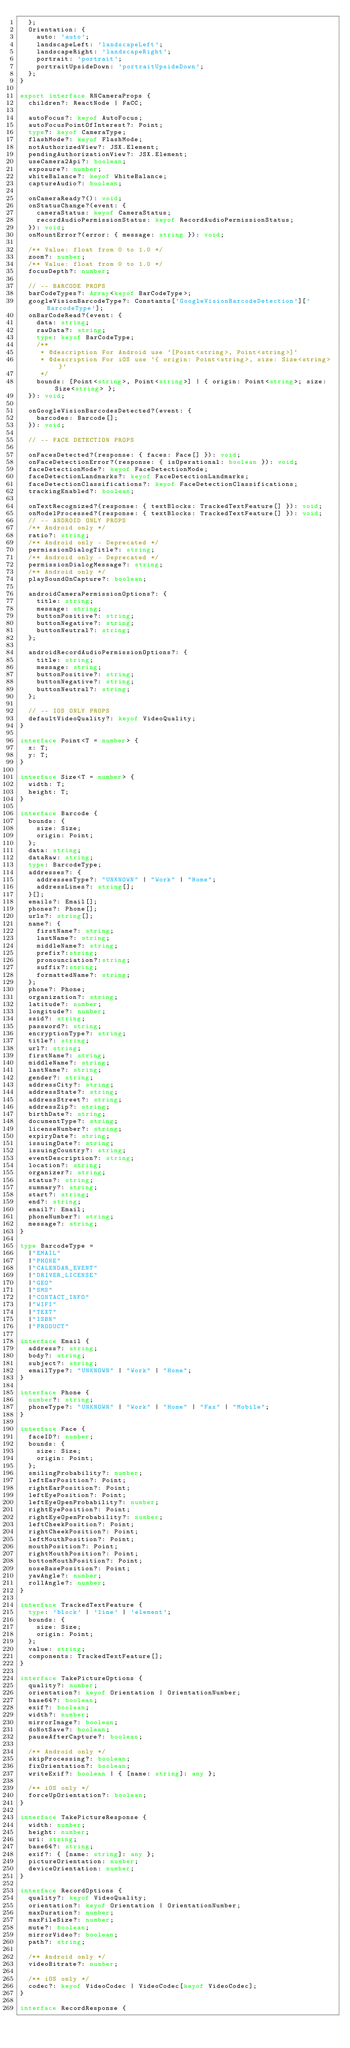Convert code to text. <code><loc_0><loc_0><loc_500><loc_500><_TypeScript_>  };
  Orientation: {
    auto: 'auto';
    landscapeLeft: 'landscapeLeft';
    landscapeRight: 'landscapeRight';
    portrait: 'portrait';
    portraitUpsideDown: 'portraitUpsideDown';
  };
}

export interface RNCameraProps {
  children?: ReactNode | FaCC;

  autoFocus?: keyof AutoFocus;
  autoFocusPointOfInterest?: Point;
  type?: keyof CameraType;
  flashMode?: keyof FlashMode;
  notAuthorizedView?: JSX.Element;
  pendingAuthorizationView?: JSX.Element;
  useCamera2Api?: boolean;
  exposure?: number;
  whiteBalance?: keyof WhiteBalance;
  captureAudio?: boolean;

  onCameraReady?(): void;
  onStatusChange?(event: {
    cameraStatus: keyof CameraStatus;
    recordAudioPermissionStatus: keyof RecordAudioPermissionStatus;
  }): void;
  onMountError?(error: { message: string }): void;

  /** Value: float from 0 to 1.0 */
  zoom?: number;
  /** Value: float from 0 to 1.0 */
  focusDepth?: number;

  // -- BARCODE PROPS
  barCodeTypes?: Array<keyof BarCodeType>;
  googleVisionBarcodeType?: Constants['GoogleVisionBarcodeDetection']['BarcodeType'];
  onBarCodeRead?(event: {
    data: string;
    rawData?: string;
    type: keyof BarCodeType;
    /**
     * @description For Android use `[Point<string>, Point<string>]`
     * @description For iOS use `{ origin: Point<string>, size: Size<string> }`
     */
    bounds: [Point<string>, Point<string>] | { origin: Point<string>; size: Size<string> };
  }): void;

  onGoogleVisionBarcodesDetected?(event: {
    barcodes: Barcode[];
  }): void;

  // -- FACE DETECTION PROPS

  onFacesDetected?(response: { faces: Face[] }): void;
  onFaceDetectionError?(response: { isOperational: boolean }): void;
  faceDetectionMode?: keyof FaceDetectionMode;
  faceDetectionLandmarks?: keyof FaceDetectionLandmarks;
  faceDetectionClassifications?: keyof FaceDetectionClassifications;
  trackingEnabled?: boolean;

  onTextRecognized?(response: { textBlocks: TrackedTextFeature[] }): void;
  onModelProcessed?(response: { textBlocks: TrackedTextFeature[] }): void;  
  // -- ANDROID ONLY PROPS
  /** Android only */
  ratio?: string;
  /** Android only - Deprecated */
  permissionDialogTitle?: string;
  /** Android only - Deprecated */
  permissionDialogMessage?: string;
  /** Android only */
  playSoundOnCapture?: boolean;

  androidCameraPermissionOptions?: {
    title: string;
    message: string;
    buttonPositive?: string;
    buttonNegative?: string;
    buttonNeutral?: string;
  };

  androidRecordAudioPermissionOptions?: {
    title: string;
    message: string;
    buttonPositive?: string;
    buttonNegative?: string;
    buttonNeutral?: string;
  };

  // -- IOS ONLY PROPS
  defaultVideoQuality?: keyof VideoQuality;
}

interface Point<T = number> {
  x: T;
  y: T;
}

interface Size<T = number> {
  width: T;
  height: T;
}

interface Barcode {
  bounds: {
    size: Size;
    origin: Point;
  };
  data: string;
  dataRaw: string;
  type: BarcodeType;
  addresses?: {
    addressesType?: "UNKNOWN" | "Work" | "Home";
    addressLines?: string[];
  }[];
  emails?: Email[];
  phones?: Phone[];
  urls?: string[];
  name?: {
    firstName?: string;
    lastName?: string;
    middleName?: string;
    prefix?:string;
    pronounciation?:string;
    suffix?:string;
    formattedName?: string;
  };
  phone?: Phone;
  organization?: string;
  latitude?: number;
  longitude?: number;
  ssid?: string;
  password?: string;
  encryptionType?: string;
  title?: string;
  url?: string;
  firstName?: string;
  middleName?: string;
  lastName?: string;
  gender?: string;
  addressCity?: string;
  addressState?: string;
  addressStreet?: string;
  addressZip?: string;
  birthDate?: string;
  documentType?: string;
  licenseNumber?: string;
  expiryDate?: string;
  issuingDate?: string;
  issuingCountry?: string;
  eventDescription?: string;
  location?: string;
  organizer?: string;
  status?: string;
  summary?: string;
  start?: string;
  end?: string;
  email?: Email;
  phoneNumber?: string;
  message?: string;
}

type BarcodeType =
  |"EMAIL"
  |"PHONE"
  |"CALENDAR_EVENT"
  |"DRIVER_LICENSE"
  |"GEO"
  |"SMS"
  |"CONTACT_INFO"
  |"WIFI"
  |"TEXT"
  |"ISBN"
  |"PRODUCT"

interface Email {
  address?: string;
  body?: string;
  subject?: string;
  emailType?: "UNKNOWN" | "Work" | "Home";
}

interface Phone {
  number?: string;
  phoneType?: "UNKNOWN" | "Work" | "Home" | "Fax" | "Mobile";
}

interface Face {
  faceID?: number;
  bounds: {
    size: Size;
    origin: Point;
  };
  smilingProbability?: number;
  leftEarPosition?: Point;
  rightEarPosition?: Point;
  leftEyePosition?: Point;
  leftEyeOpenProbability?: number;
  rightEyePosition?: Point;
  rightEyeOpenProbability?: number;
  leftCheekPosition?: Point;
  rightCheekPosition?: Point;
  leftMouthPosition?: Point;
  mouthPosition?: Point;
  rightMouthPosition?: Point;
  bottomMouthPosition?: Point;
  noseBasePosition?: Point;
  yawAngle?: number;
  rollAngle?: number;
}

interface TrackedTextFeature {
  type: 'block' | 'line' | 'element';
  bounds: {
    size: Size;
    origin: Point;
  };
  value: string;
  components: TrackedTextFeature[];
}

interface TakePictureOptions {
  quality?: number;
  orientation?: keyof Orientation | OrientationNumber;
  base64?: boolean;
  exif?: boolean;
  width?: number;
  mirrorImage?: boolean;
  doNotSave?: boolean;
  pauseAfterCapture?: boolean;

  /** Android only */
  skipProcessing?: boolean;
  fixOrientation?: boolean;
  writeExif?: boolean | { [name: string]: any };

  /** iOS only */
  forceUpOrientation?: boolean;
}

interface TakePictureResponse {
  width: number;
  height: number;
  uri: string;
  base64?: string;
  exif?: { [name: string]: any };
  pictureOrientation: number;
  deviceOrientation: number;
}

interface RecordOptions {
  quality?: keyof VideoQuality;
  orientation?: keyof Orientation | OrientationNumber;
  maxDuration?: number;
  maxFileSize?: number;
  mute?: boolean;
  mirrorVideo?: boolean;
  path?: string;

  /** Android only */
  videoBitrate?: number;

  /** iOS only */
  codec?: keyof VideoCodec | VideoCodec[keyof VideoCodec];
}

interface RecordResponse {</code> 